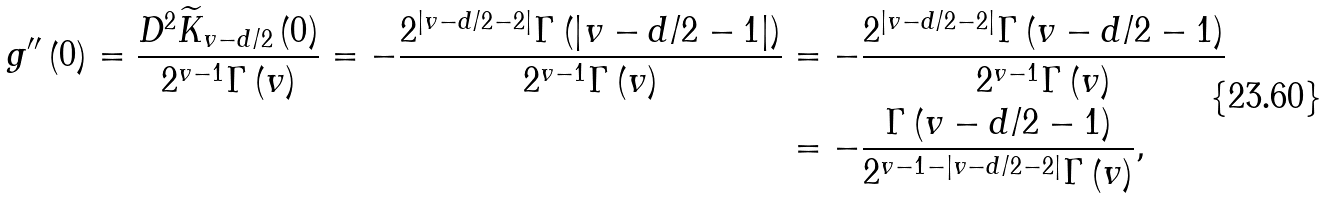Convert formula to latex. <formula><loc_0><loc_0><loc_500><loc_500>g ^ { \prime \prime } \left ( 0 \right ) = \frac { D ^ { 2 } \widetilde { K } _ { v - d / 2 } \left ( 0 \right ) } { 2 ^ { v - 1 } \Gamma \left ( v \right ) } = - \frac { 2 ^ { \left | v - d / 2 - 2 \right | } \Gamma \left ( \left | v - d / 2 - 1 \right | \right ) } { 2 ^ { v - 1 } \Gamma \left ( v \right ) } & = - \frac { 2 ^ { \left | v - d / 2 - 2 \right | } \Gamma \left ( v - d / 2 - 1 \right ) } { 2 ^ { v - 1 } \Gamma \left ( v \right ) } \\ & = - \frac { \Gamma \left ( v - d / 2 - 1 \right ) } { 2 ^ { v - 1 - \left | v - d / 2 - 2 \right | } \Gamma \left ( v \right ) } ,</formula> 